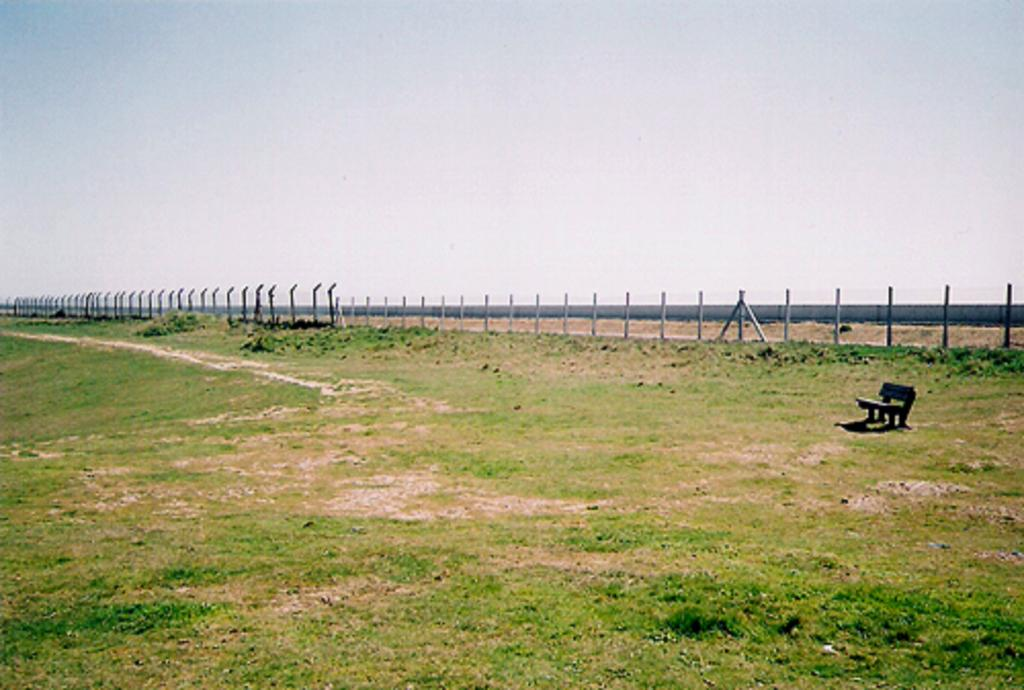What is located on the ground in the image? There is a bench on the ground in the image. What type of vegetation can be seen in the image? There is grass visible in the image. What architectural features are present in the image? There is a fence and a wall in the image. What part of the natural environment is visible in the image? The sky is visible in the image. How many hands are visible in the image? There are no hands visible in the image. What type of verse can be heard recited by the dogs in the image? There are no dogs or verses present in the image. 